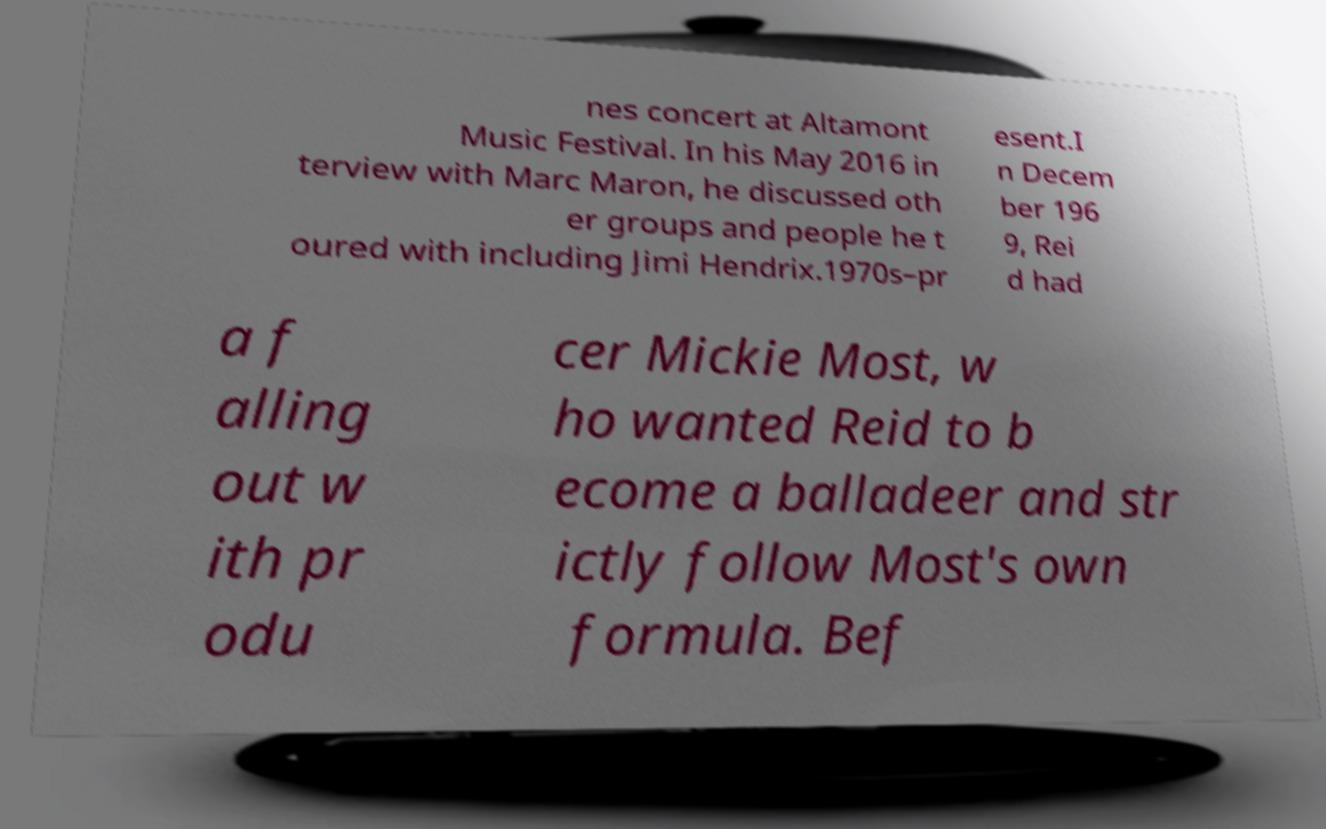For documentation purposes, I need the text within this image transcribed. Could you provide that? nes concert at Altamont Music Festival. In his May 2016 in terview with Marc Maron, he discussed oth er groups and people he t oured with including Jimi Hendrix.1970s–pr esent.I n Decem ber 196 9, Rei d had a f alling out w ith pr odu cer Mickie Most, w ho wanted Reid to b ecome a balladeer and str ictly follow Most's own formula. Bef 